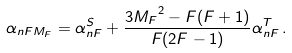<formula> <loc_0><loc_0><loc_500><loc_500>\alpha _ { n F M _ { F } } = \alpha _ { n F } ^ { S } + \frac { 3 { M _ { F } } ^ { 2 } - F ( F + 1 ) } { F ( 2 F - 1 ) } \alpha _ { n F } ^ { T } \, .</formula> 